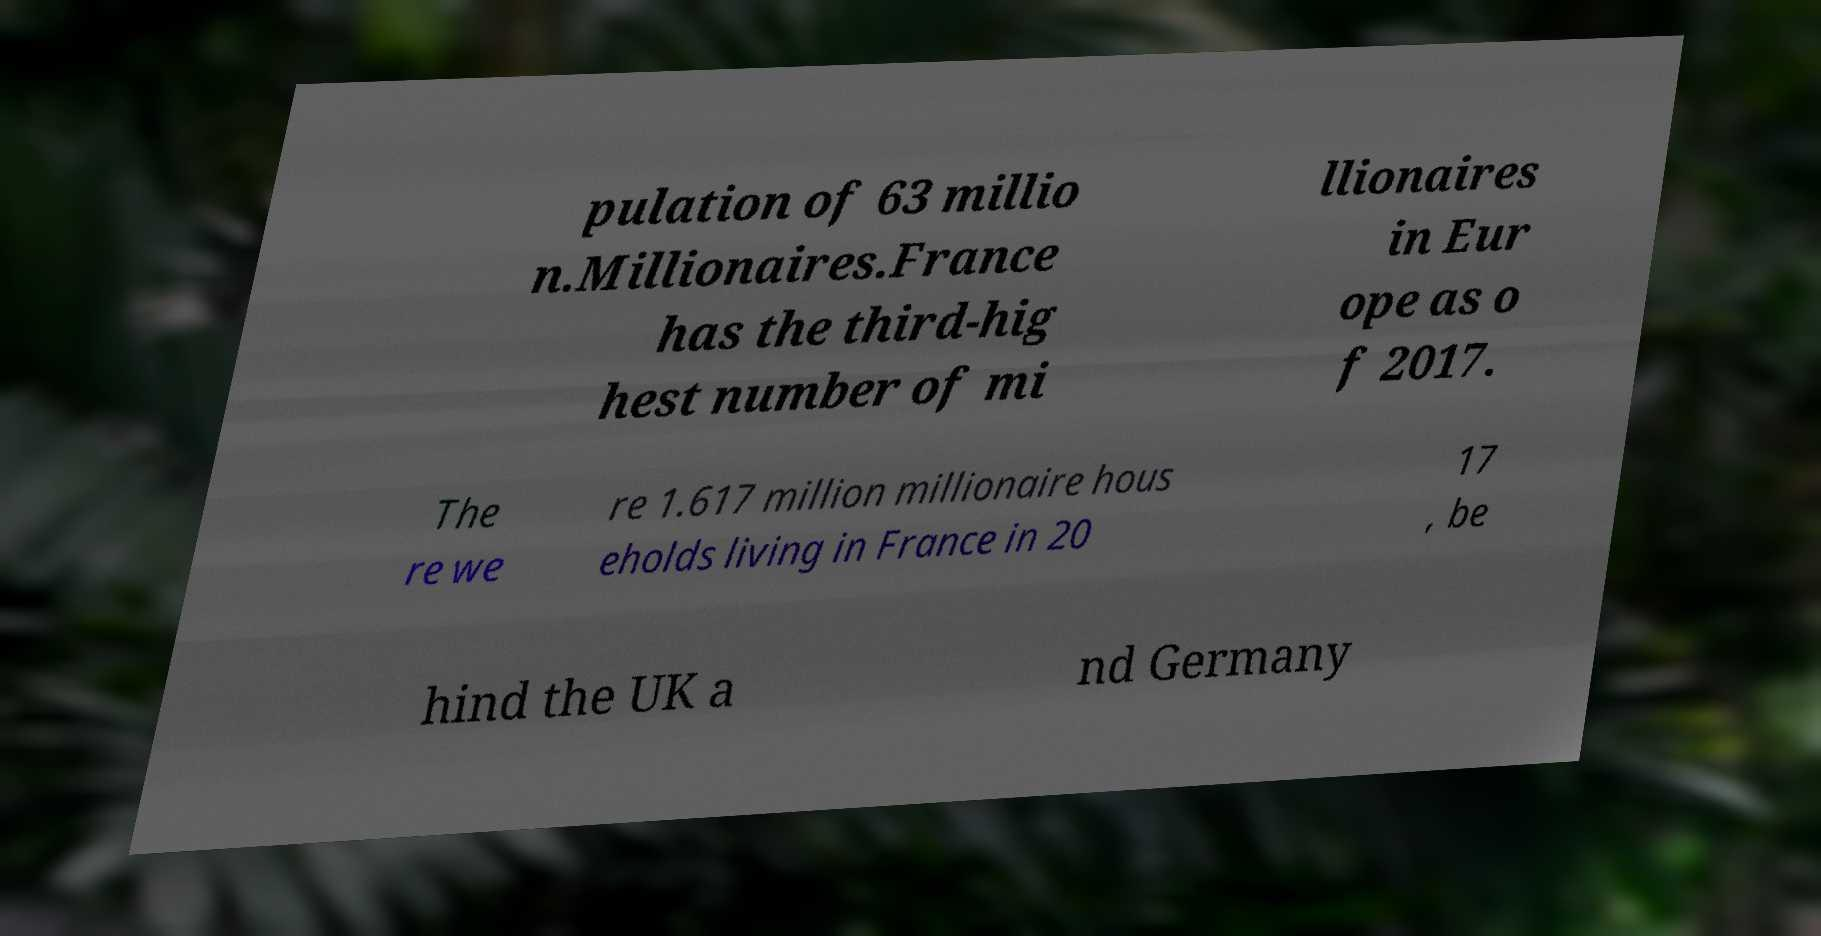Please read and relay the text visible in this image. What does it say? pulation of 63 millio n.Millionaires.France has the third-hig hest number of mi llionaires in Eur ope as o f 2017. The re we re 1.617 million millionaire hous eholds living in France in 20 17 , be hind the UK a nd Germany 